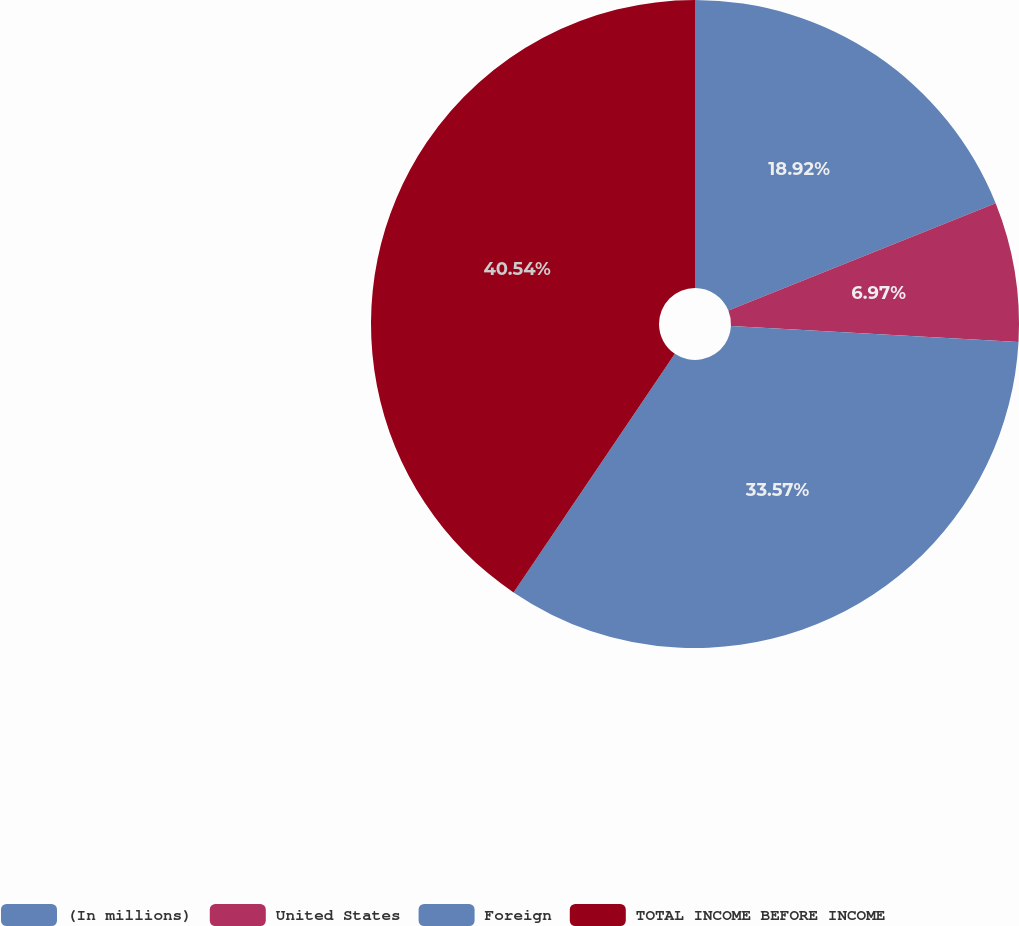Convert chart to OTSL. <chart><loc_0><loc_0><loc_500><loc_500><pie_chart><fcel>(In millions)<fcel>United States<fcel>Foreign<fcel>TOTAL INCOME BEFORE INCOME<nl><fcel>18.92%<fcel>6.97%<fcel>33.57%<fcel>40.54%<nl></chart> 